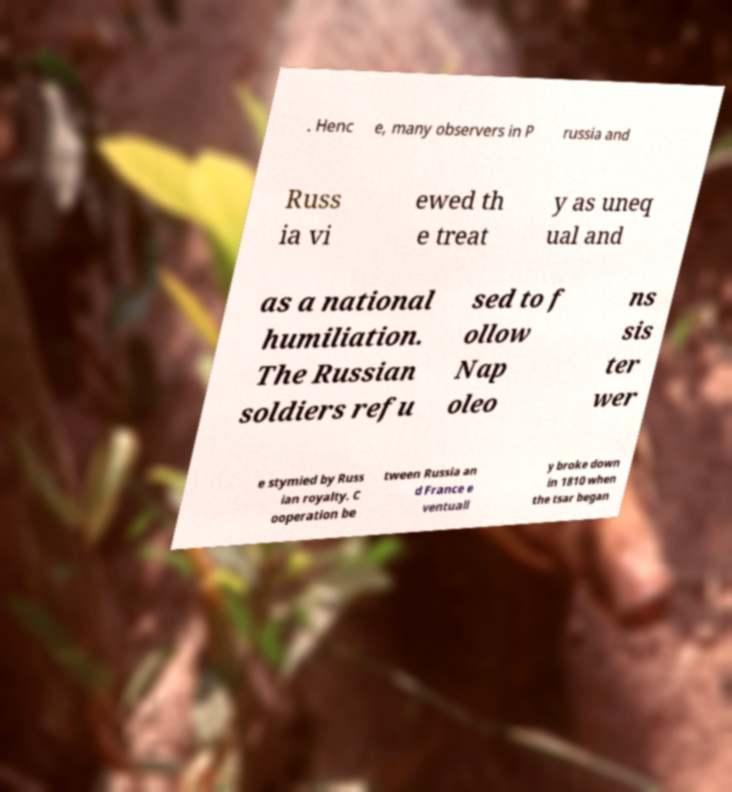Could you assist in decoding the text presented in this image and type it out clearly? . Henc e, many observers in P russia and Russ ia vi ewed th e treat y as uneq ual and as a national humiliation. The Russian soldiers refu sed to f ollow Nap oleo ns sis ter wer e stymied by Russ ian royalty. C ooperation be tween Russia an d France e ventuall y broke down in 1810 when the tsar began 